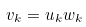Convert formula to latex. <formula><loc_0><loc_0><loc_500><loc_500>v _ { k } = u _ { k } w _ { k }</formula> 